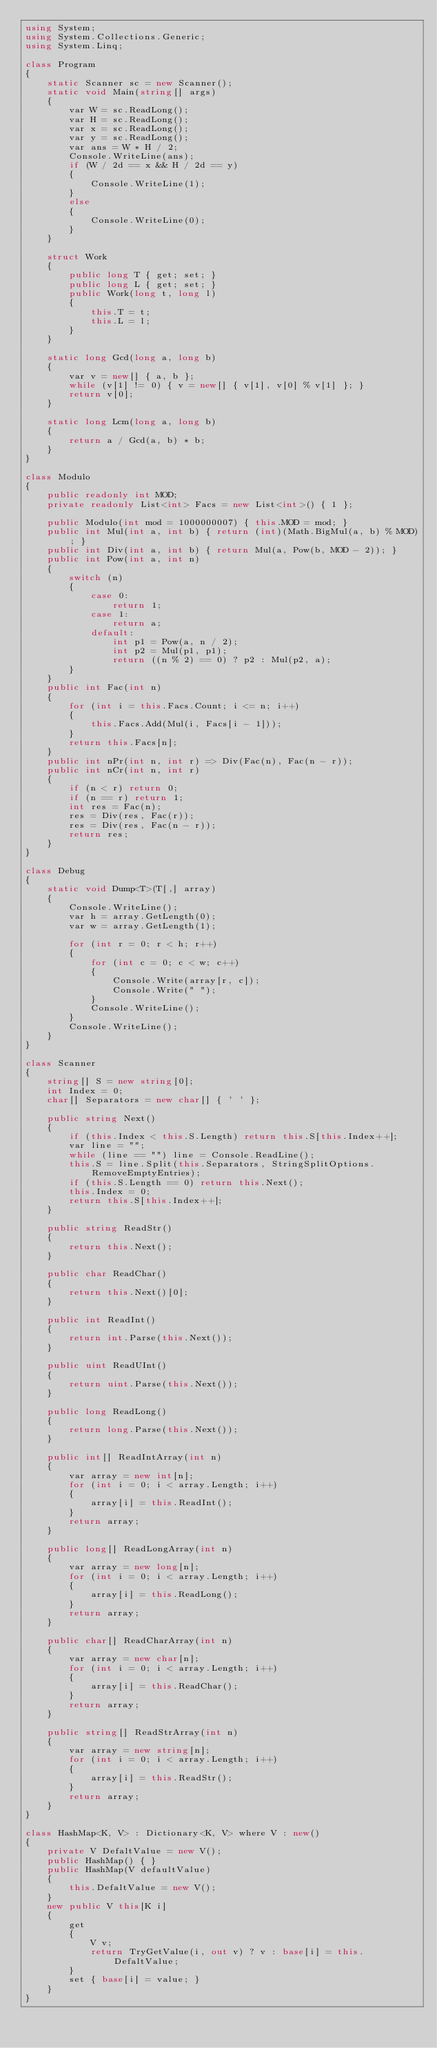<code> <loc_0><loc_0><loc_500><loc_500><_C#_>using System;
using System.Collections.Generic;
using System.Linq;

class Program
{
    static Scanner sc = new Scanner();
    static void Main(string[] args)
    {
        var W = sc.ReadLong();
        var H = sc.ReadLong();
        var x = sc.ReadLong();
        var y = sc.ReadLong();
        var ans = W * H / 2;
        Console.WriteLine(ans);
        if (W / 2d == x && H / 2d == y)
        {
            Console.WriteLine(1);
        }
        else
        {
            Console.WriteLine(0);
        }
    }

    struct Work
    {
        public long T { get; set; }
        public long L { get; set; }
        public Work(long t, long l)
        {
            this.T = t;
            this.L = l;
        }
    }

    static long Gcd(long a, long b)
    {
        var v = new[] { a, b };
        while (v[1] != 0) { v = new[] { v[1], v[0] % v[1] }; }
        return v[0];
    }

    static long Lcm(long a, long b)
    {
        return a / Gcd(a, b) * b;
    }
}

class Modulo
{
    public readonly int MOD;
    private readonly List<int> Facs = new List<int>() { 1 };

    public Modulo(int mod = 1000000007) { this.MOD = mod; }
    public int Mul(int a, int b) { return (int)(Math.BigMul(a, b) % MOD); }
    public int Div(int a, int b) { return Mul(a, Pow(b, MOD - 2)); }
    public int Pow(int a, int n)
    {
        switch (n)
        {
            case 0:
                return 1;
            case 1:
                return a;
            default:
                int p1 = Pow(a, n / 2);
                int p2 = Mul(p1, p1);
                return ((n % 2) == 0) ? p2 : Mul(p2, a);
        }
    }
    public int Fac(int n)
    {
        for (int i = this.Facs.Count; i <= n; i++)
        {
            this.Facs.Add(Mul(i, Facs[i - 1]));
        }
        return this.Facs[n];
    }
    public int nPr(int n, int r) => Div(Fac(n), Fac(n - r));
    public int nCr(int n, int r)
    {
        if (n < r) return 0;
        if (n == r) return 1;
        int res = Fac(n);
        res = Div(res, Fac(r));
        res = Div(res, Fac(n - r));
        return res;
    }
}

class Debug
{
    static void Dump<T>(T[,] array)
    {
        Console.WriteLine();
        var h = array.GetLength(0);
        var w = array.GetLength(1);

        for (int r = 0; r < h; r++)
        {
            for (int c = 0; c < w; c++)
            {
                Console.Write(array[r, c]);
                Console.Write(" ");
            }
            Console.WriteLine();
        }
        Console.WriteLine();
    }
}

class Scanner
{
    string[] S = new string[0];
    int Index = 0;
    char[] Separators = new char[] { ' ' };

    public string Next()
    {
        if (this.Index < this.S.Length) return this.S[this.Index++];
        var line = "";
        while (line == "") line = Console.ReadLine();
        this.S = line.Split(this.Separators, StringSplitOptions.RemoveEmptyEntries);
        if (this.S.Length == 0) return this.Next();
        this.Index = 0;
        return this.S[this.Index++];
    }

    public string ReadStr()
    {
        return this.Next();
    }

    public char ReadChar()
    {
        return this.Next()[0];
    }

    public int ReadInt()
    {
        return int.Parse(this.Next());
    }

    public uint ReadUInt()
    {
        return uint.Parse(this.Next());
    }

    public long ReadLong()
    {
        return long.Parse(this.Next());
    }

    public int[] ReadIntArray(int n)
    {
        var array = new int[n];
        for (int i = 0; i < array.Length; i++)
        {
            array[i] = this.ReadInt();
        }
        return array;
    }

    public long[] ReadLongArray(int n)
    {
        var array = new long[n];
        for (int i = 0; i < array.Length; i++)
        {
            array[i] = this.ReadLong();
        }
        return array;
    }

    public char[] ReadCharArray(int n)
    {
        var array = new char[n];
        for (int i = 0; i < array.Length; i++)
        {
            array[i] = this.ReadChar();
        }
        return array;
    }

    public string[] ReadStrArray(int n)
    {
        var array = new string[n];
        for (int i = 0; i < array.Length; i++)
        {
            array[i] = this.ReadStr();
        }
        return array;
    }
}

class HashMap<K, V> : Dictionary<K, V> where V : new()
{
    private V DefaltValue = new V();
    public HashMap() { }
    public HashMap(V defaultValue)
    {
        this.DefaltValue = new V();
    }
    new public V this[K i]
    {
        get
        {
            V v;
            return TryGetValue(i, out v) ? v : base[i] = this.DefaltValue;
        }
        set { base[i] = value; }
    }
}</code> 